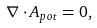Convert formula to latex. <formula><loc_0><loc_0><loc_500><loc_500>\nabla \cdot { A } _ { p o t } = 0 ,</formula> 